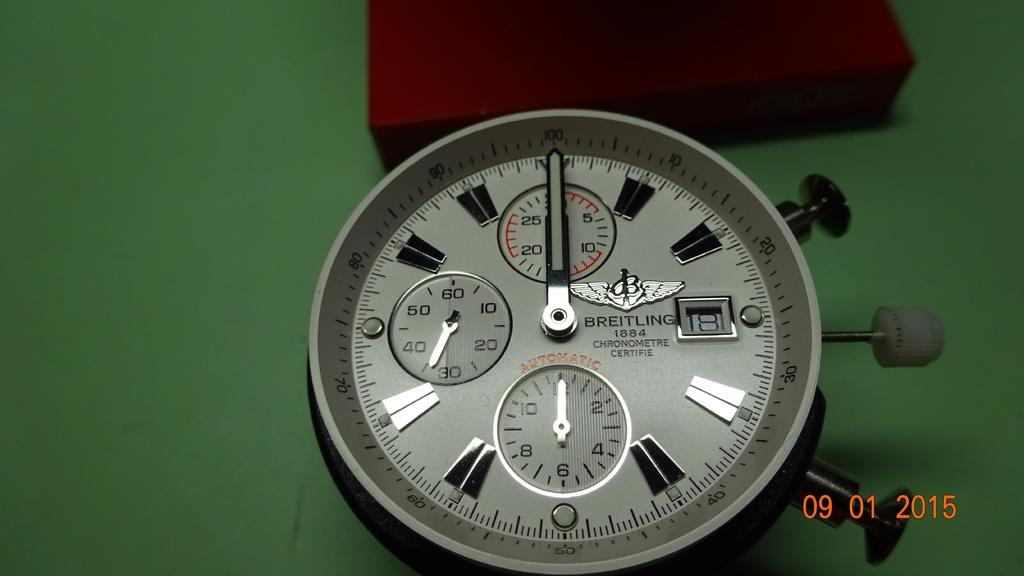<image>
Create a compact narrative representing the image presented. Face of a watch that says BREITLING next to a red and black box. 